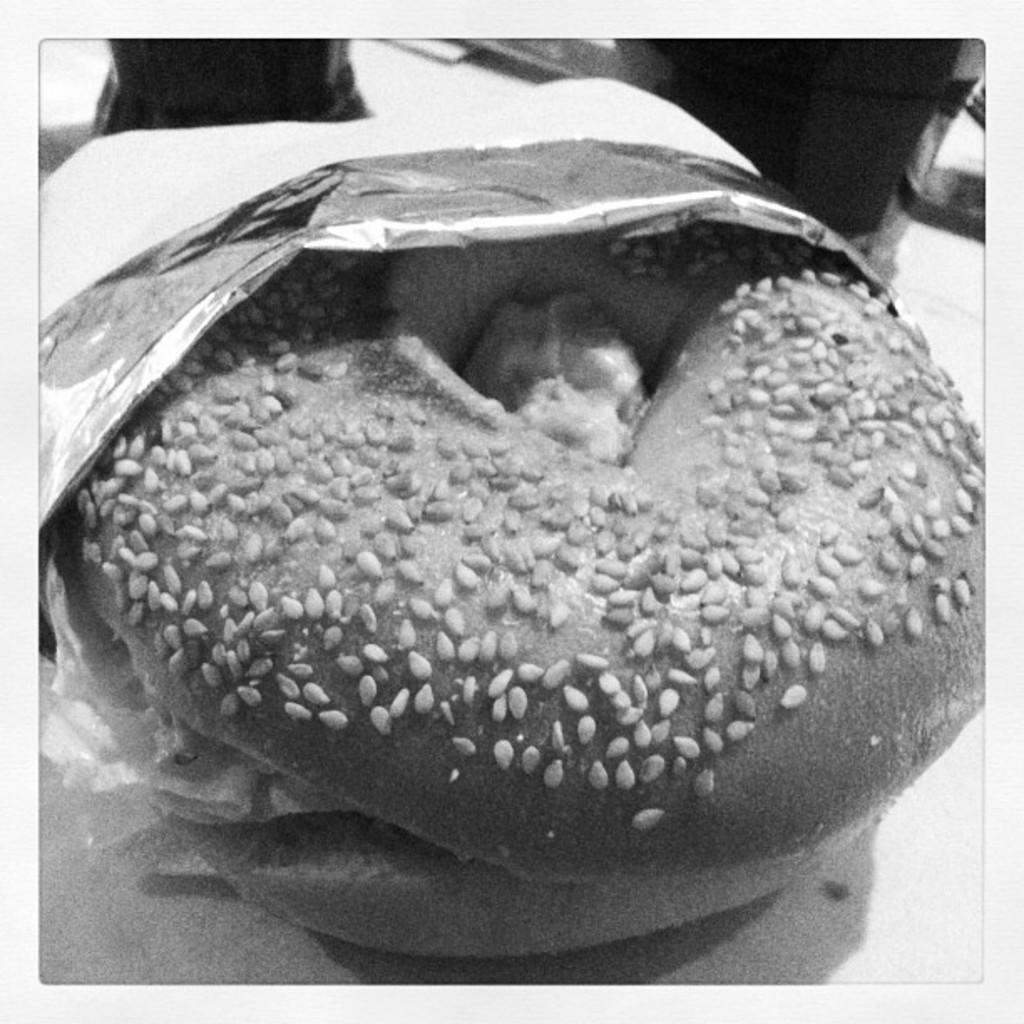What is the main subject of the image? The main subject of the image is an edible. How is the edible being presented in the image? The edible is placed in a silver cover. Can you tell me how many frogs are sitting on the edible in the image? There are no frogs present in the image; it features an edible placed in a silver cover. What type of education is being provided in the image? There is no reference to education in the image, as it only features an edible placed in a silver cover. 